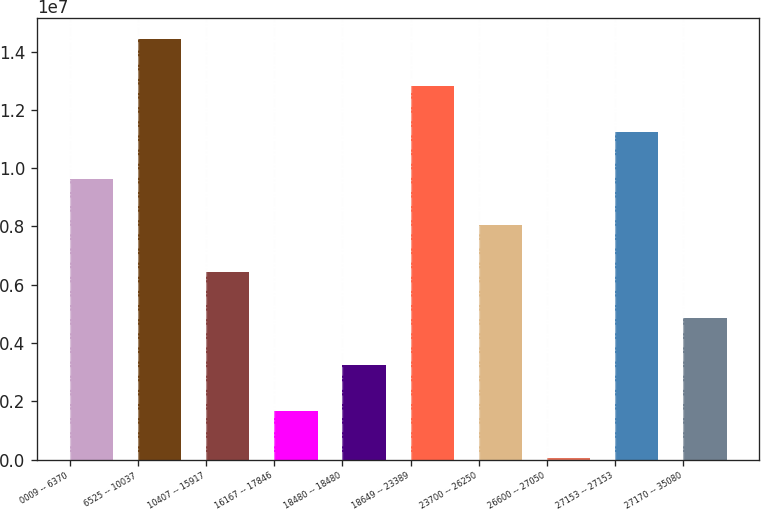Convert chart. <chart><loc_0><loc_0><loc_500><loc_500><bar_chart><fcel>0009 -- 6370<fcel>6525 -- 10037<fcel>10407 -- 15917<fcel>16167 -- 17846<fcel>18480 -- 18480<fcel>18649 -- 23389<fcel>23700 -- 26250<fcel>26600 -- 27050<fcel>27153 -- 27153<fcel>27170 -- 35080<nl><fcel>9.63336e+06<fcel>1.44189e+07<fcel>6.443e+06<fcel>1.65747e+06<fcel>3.25265e+06<fcel>1.28237e+07<fcel>8.03818e+06<fcel>62295<fcel>1.12285e+07<fcel>4.84783e+06<nl></chart> 